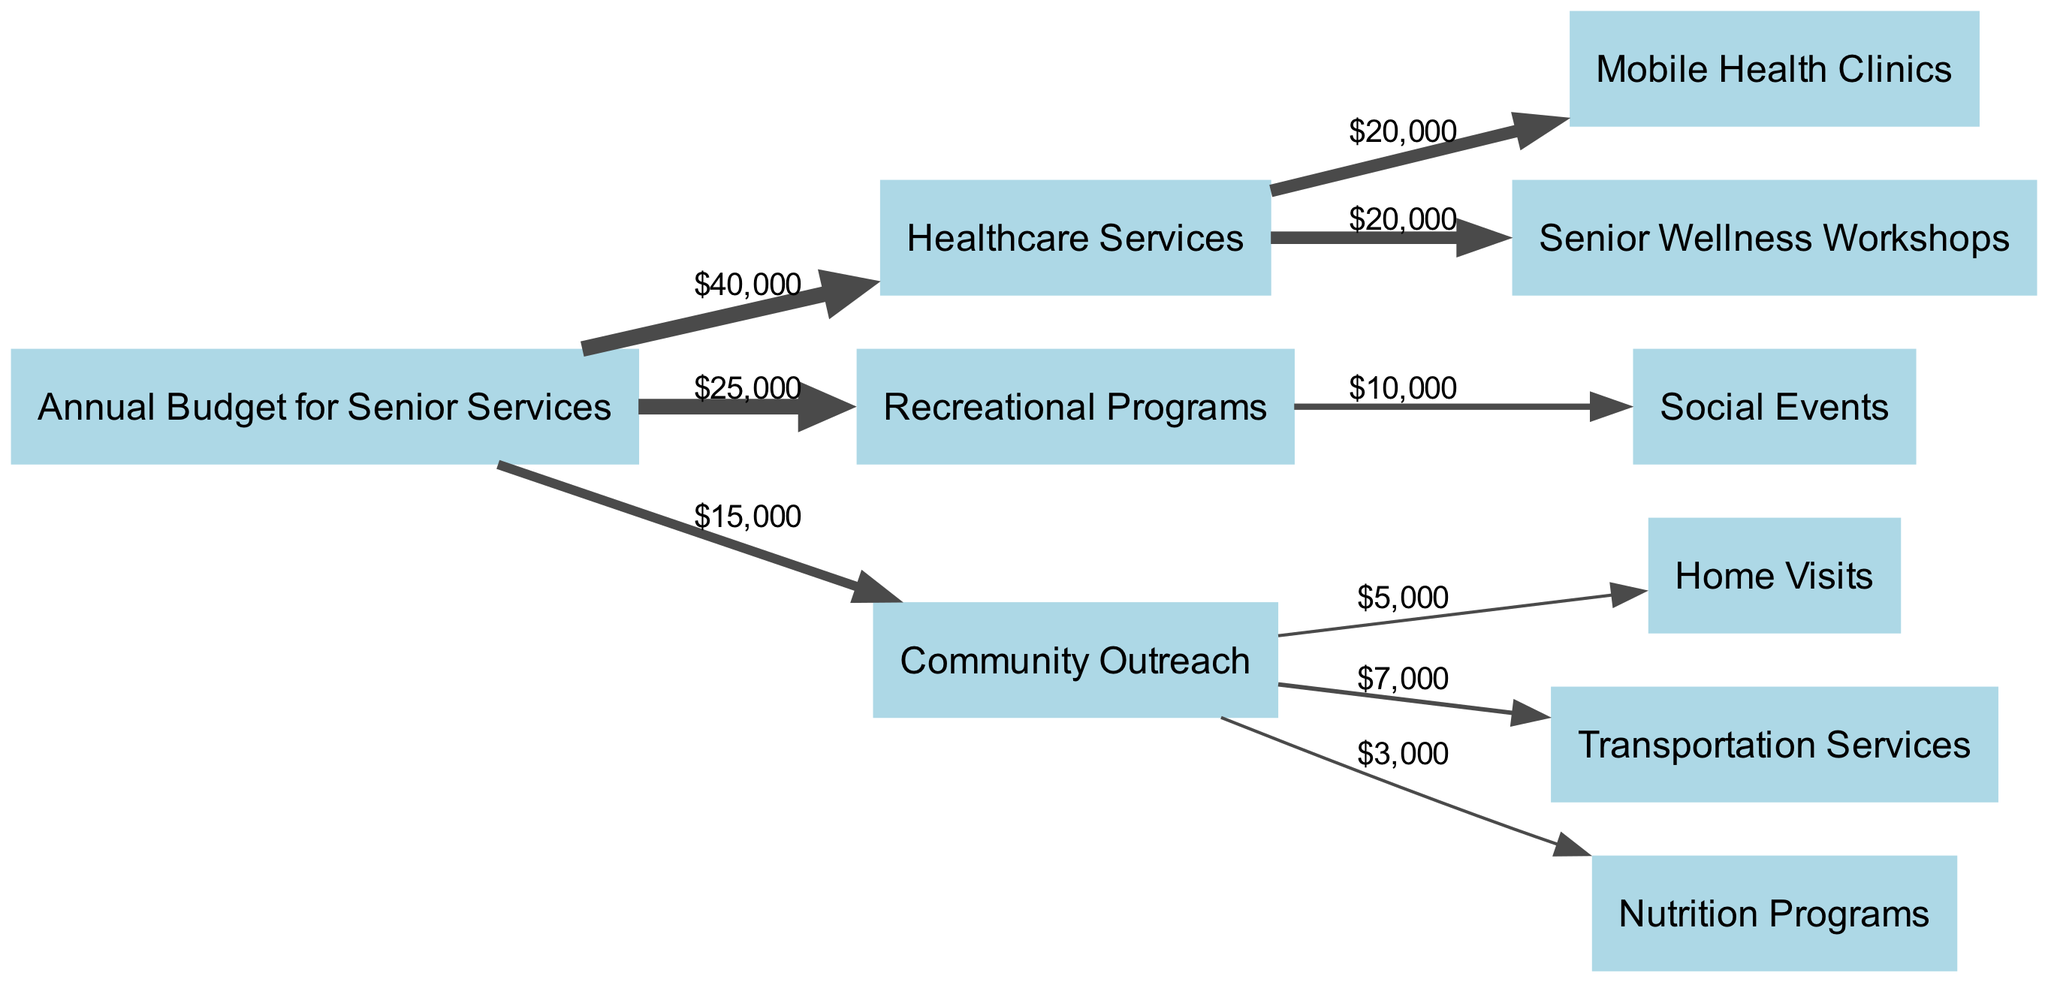What is the total annual budget allocated for senior services? The total annual budget for senior services is represented as the source node and can be identified as the sum of the values flowing out of it. Adding the healthcare services, recreational programs, and community outreach gives us $40,000 + $25,000 + $15,000 = $80,000.
Answer: $80,000 How much money is allocated to healthcare services? Looking at the direct flow from the annual budget to healthcare services in the diagram, we see that the value represented is $40,000.
Answer: $40,000 What are the total funds allocated to recreational programs? The diagram indicates that the flow from the annual budget to recreational programs is $25,000. This is the only amount directed to recreational programs, thus no additional calculations are needed.
Answer: $25,000 Which service receives the least funding? By examining the flows from community outreach services, we can see home visits, transportation services, and nutrition programs. Among these, nutrition programs receive only $3,000, which is the least.
Answer: Nutrition Programs How much funding is allocated for mobile health clinics? Mobile health clinics are part of the healthcare services portion. The amount directed from healthcare services to mobile health clinics is $20,000.
Answer: $20,000 What is the total funding directed towards community outreach? Community outreach, as indicated in the diagram, receives $15,000 from the annual budget. The only amount allocated towards community outreach is this $15,000.
Answer: $15,000 Which program has the highest allocated budget? Within the healthcare services node, there are mobile health clinics and senior wellness workshops, each receiving $20,000. Comparing all nodes, healthcare is highlighted with the largest amount at $40,000.
Answer: Healthcare Services How much total funding goes to home visits and transportation services? Home visits receive $5,000 while transportation services receive $7,000, totaling $5,000 + $7,000 = $12,000 from the community outreach allocation.
Answer: $12,000 What percentage of the total budget is allocated to healthcare services? To find the percentage of the total annual budget that goes to healthcare services, we take the allotted amount of healthcare services, which is $40,000, and divide it by the total budget $80,000. This gives us (40,000 / 80,000) * 100 = 50%.
Answer: 50% 